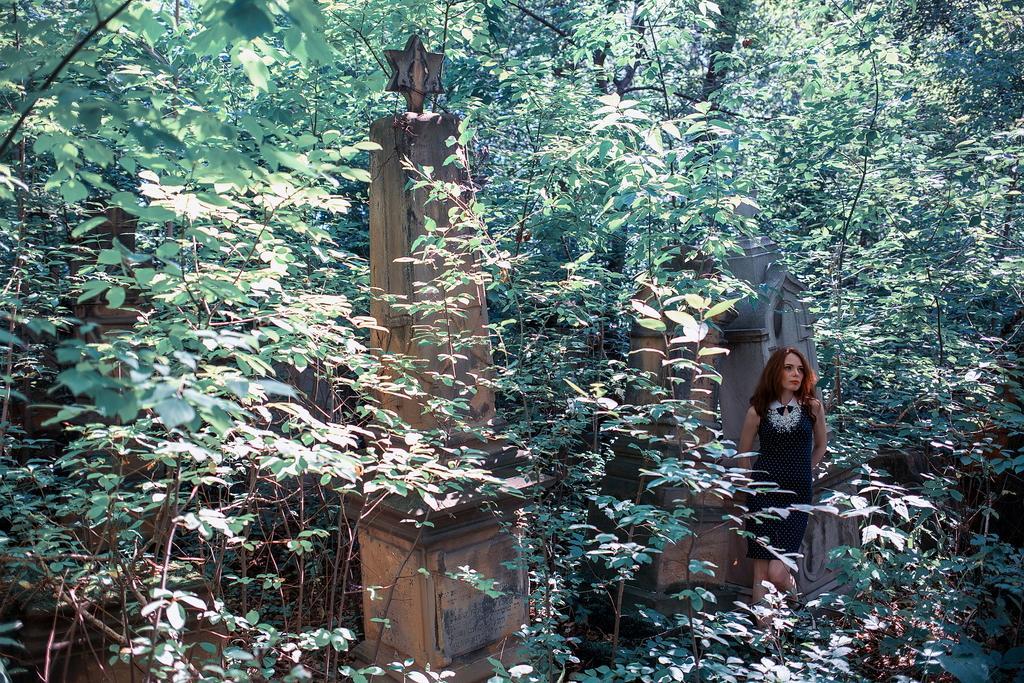In one or two sentences, can you explain what this image depicts? In the picture we can see a forest area with full of trees and some sculptured stones in it and one woman standing near to it and she is wearing a black dress. 